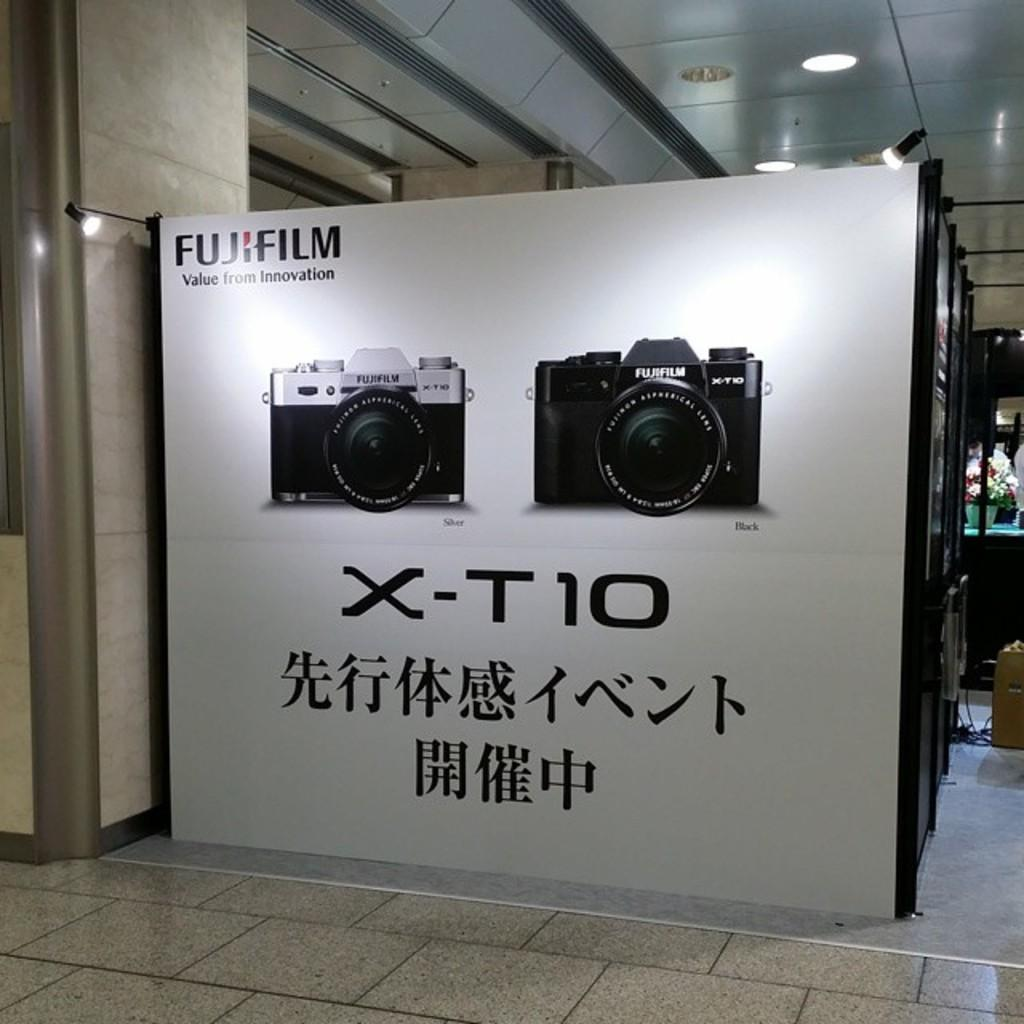<image>
Summarize the visual content of the image. An ad by Fujifilm for the X-T10 camera. 